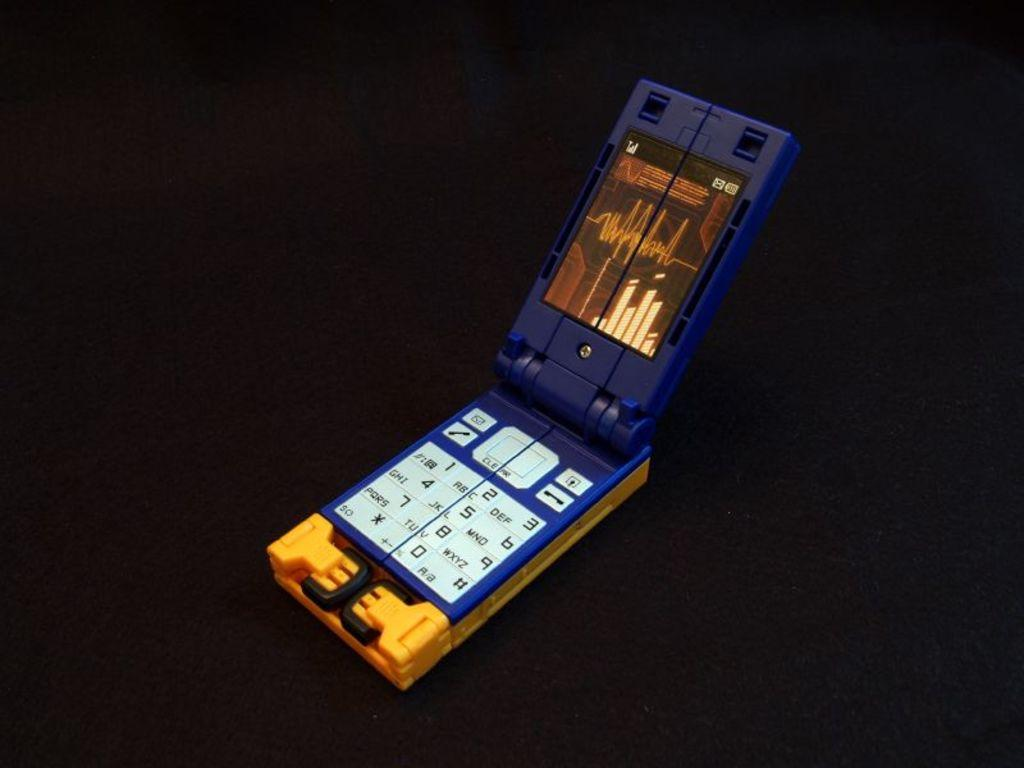Provide a one-sentence caption for the provided image. a pretend flip phone with the numbers 1-0 on it. 